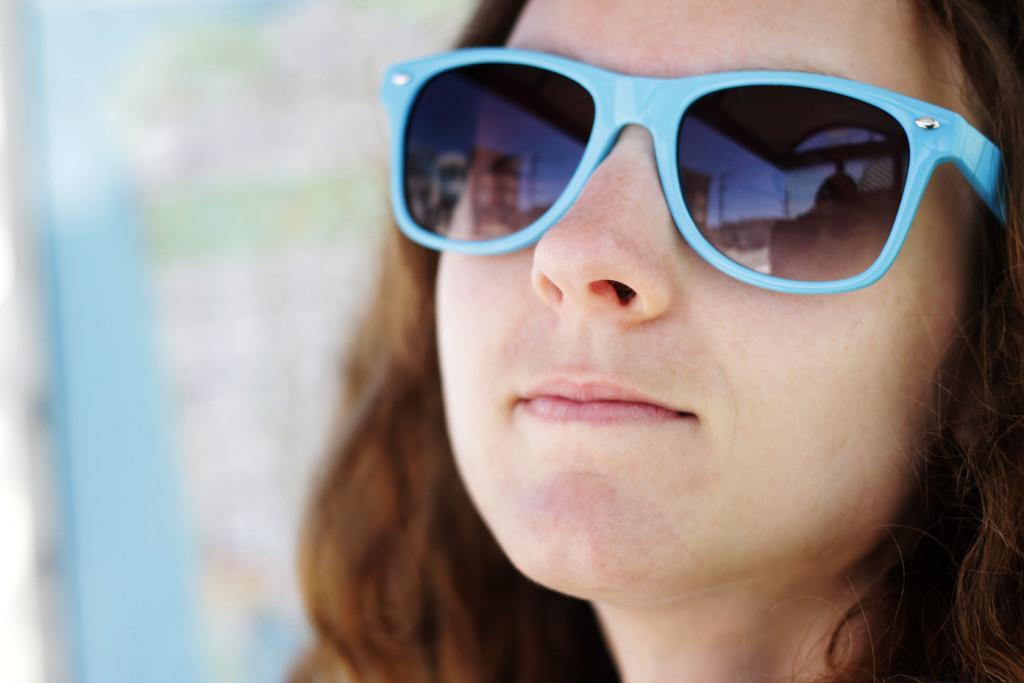Please provide a concise description of this image. This image consists of a woman. Only the face is visible. She is wearing goggles. 